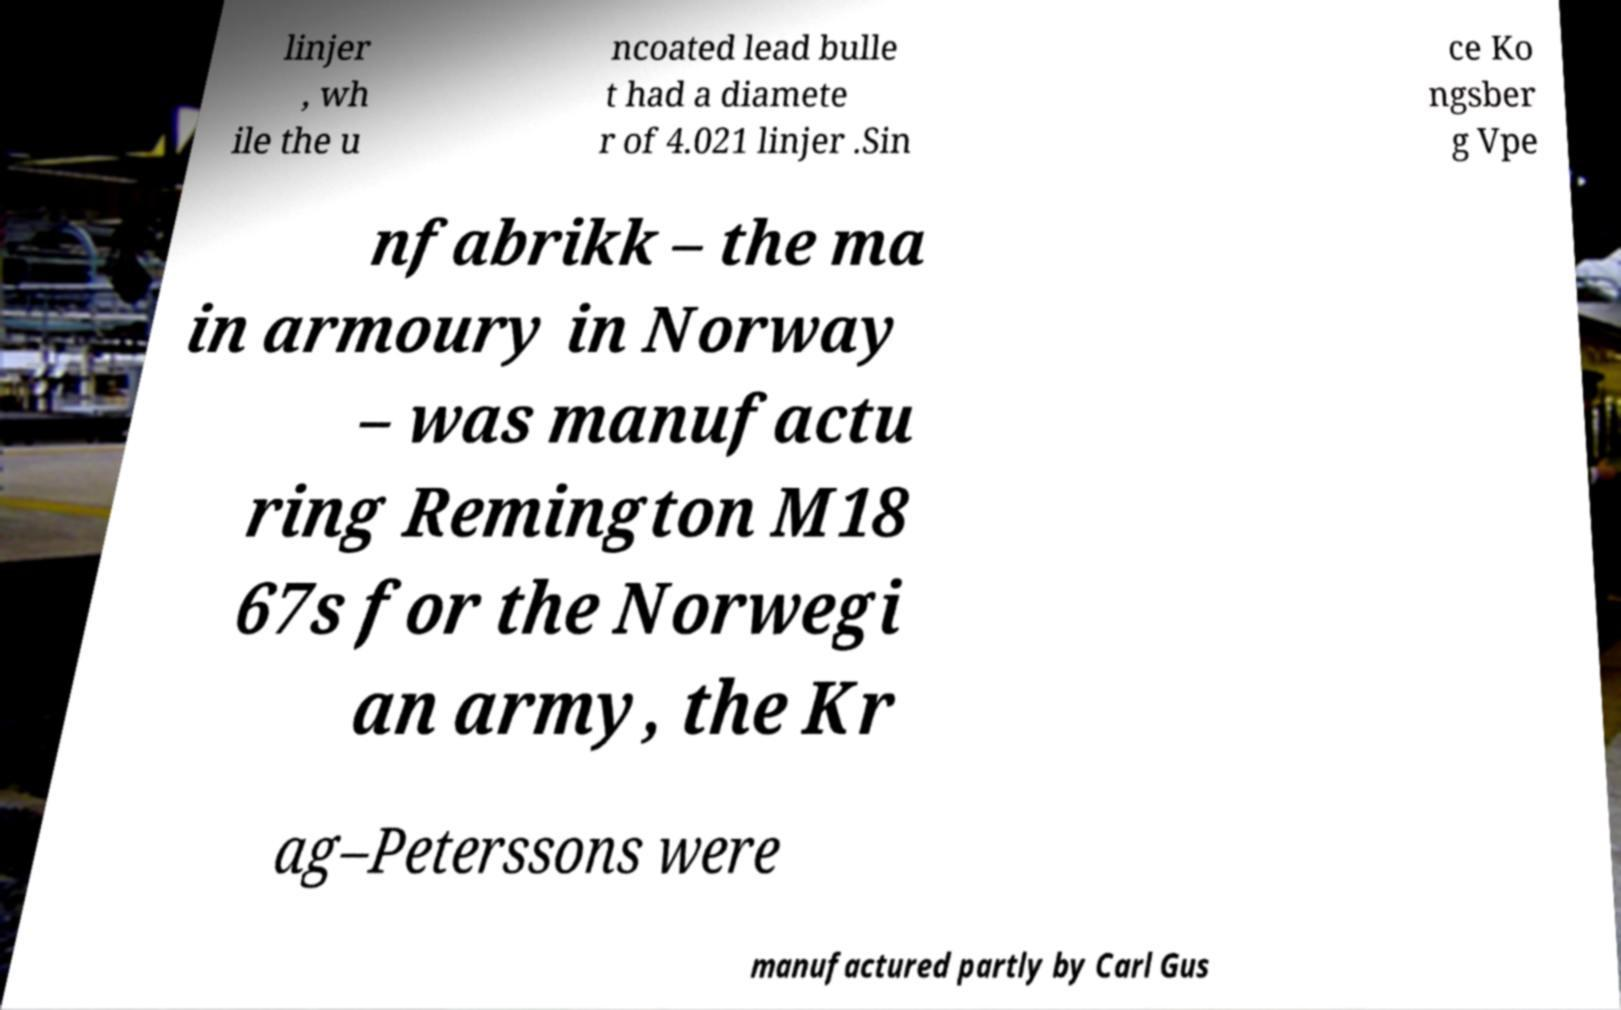There's text embedded in this image that I need extracted. Can you transcribe it verbatim? linjer , wh ile the u ncoated lead bulle t had a diamete r of 4.021 linjer .Sin ce Ko ngsber g Vpe nfabrikk – the ma in armoury in Norway – was manufactu ring Remington M18 67s for the Norwegi an army, the Kr ag–Peterssons were manufactured partly by Carl Gus 